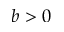Convert formula to latex. <formula><loc_0><loc_0><loc_500><loc_500>b > 0</formula> 